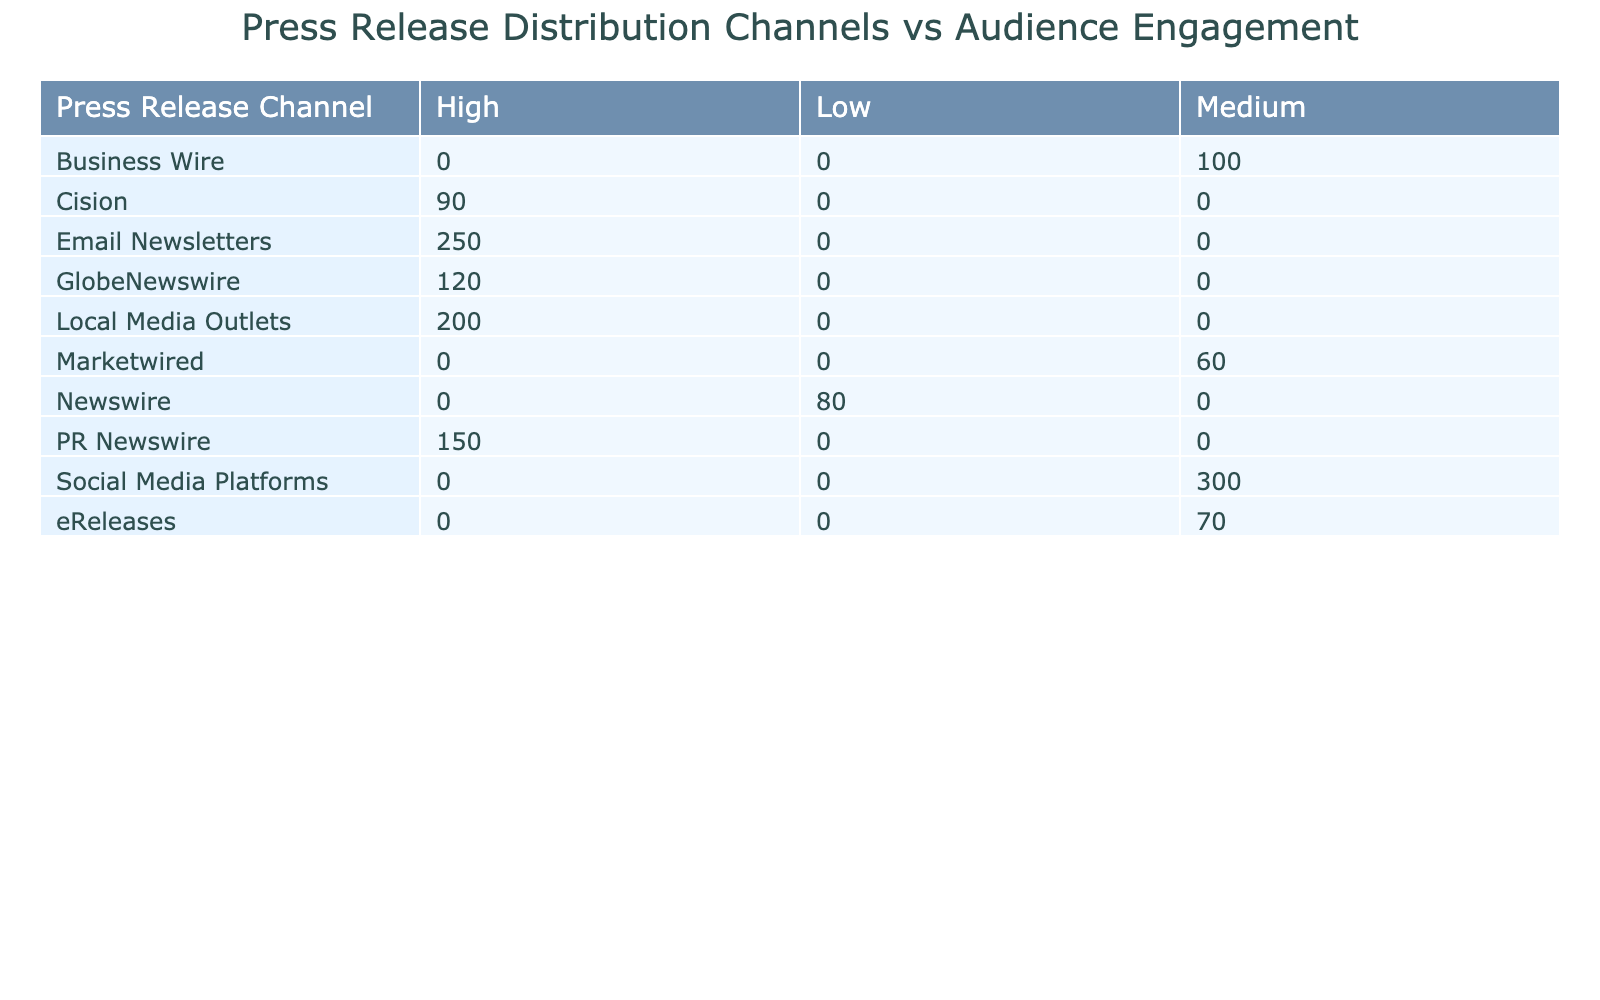What is the average open rate for the press release channel with the highest number of releases? The press release channel with the highest number of releases is Email Newsletters, which has an average open rate of 65%.
Answer: 65% Which press release channel has the lowest audience engagement level? The press release channel with the lowest audience engagement level is Newswire, which is classified as Low.
Answer: Newswire What is the total number of releases for Medium audience engagement channels? The total number of releases for Medium channels can be calculated by summing the values: Business Wire (100) + eReleases (70) + Marketwired (60) + Social Media Platforms (300) = 530.
Answer: 530 Are there more press release channels with High engagement than those with Low engagement? Yes, there are four channels with High engagement (PR Newswire, GlobeNewswire, Cision, Local Media Outlets, Email Newsletters) and only one channel with Low engagement (Newswire).
Answer: Yes What is the average number of releases for channels with High audience engagement? To calculate the average for High engagement channels: (150 + 120 + 90 + 200 + 250) = 810 for 5 channels, the average is 810/5 = 162.
Answer: 162 How many more releases does the High audience engagement channel with the least releases have compared to the Low audience engagement channel? The High engagement channel with the least releases is Cision (90), while the Low engagement channel is Newswire (80). The difference is 90 - 80 = 10.
Answer: 10 What percentage of the total press releases are distributed through Social Media Platforms? The total number of releases is 150 + 100 + 120 + 70 + 80 + 90 + 60 + 200 + 300 + 250 = 1,520. The number of releases through Social Media Platforms is 300, so the percentage is (300/1520)*100 = 19.74%.
Answer: 19.74% Is it true that Email Newsletters have the highest average open rate? Yes, Email Newsletters have an average open rate of 65%, which is higher than all other channels listed in the table.
Answer: Yes Which channel has the highest number of releases and what is its average open rate? The channel with the highest number of releases is Email Newsletters with 250 releases, and its average open rate is 65%.
Answer: Email Newsletters, 65% 